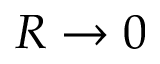Convert formula to latex. <formula><loc_0><loc_0><loc_500><loc_500>R \to 0</formula> 